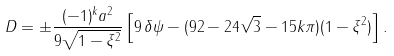<formula> <loc_0><loc_0><loc_500><loc_500>D = \pm \frac { ( - 1 ) ^ { k } a ^ { 2 } } { 9 \sqrt { 1 - \xi ^ { 2 } } } \left [ 9 \, \delta \psi - ( 9 2 - 2 4 \sqrt { 3 } - 1 5 k \pi ) ( 1 - \xi ^ { 2 } ) \right ] .</formula> 